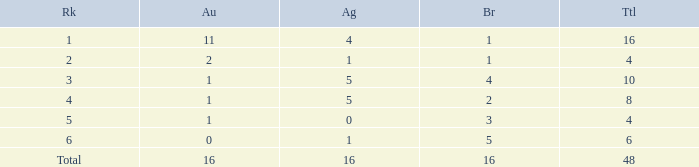What is the total gold that has bronze less than 2, a silver of 1 and total more than 4? None. 